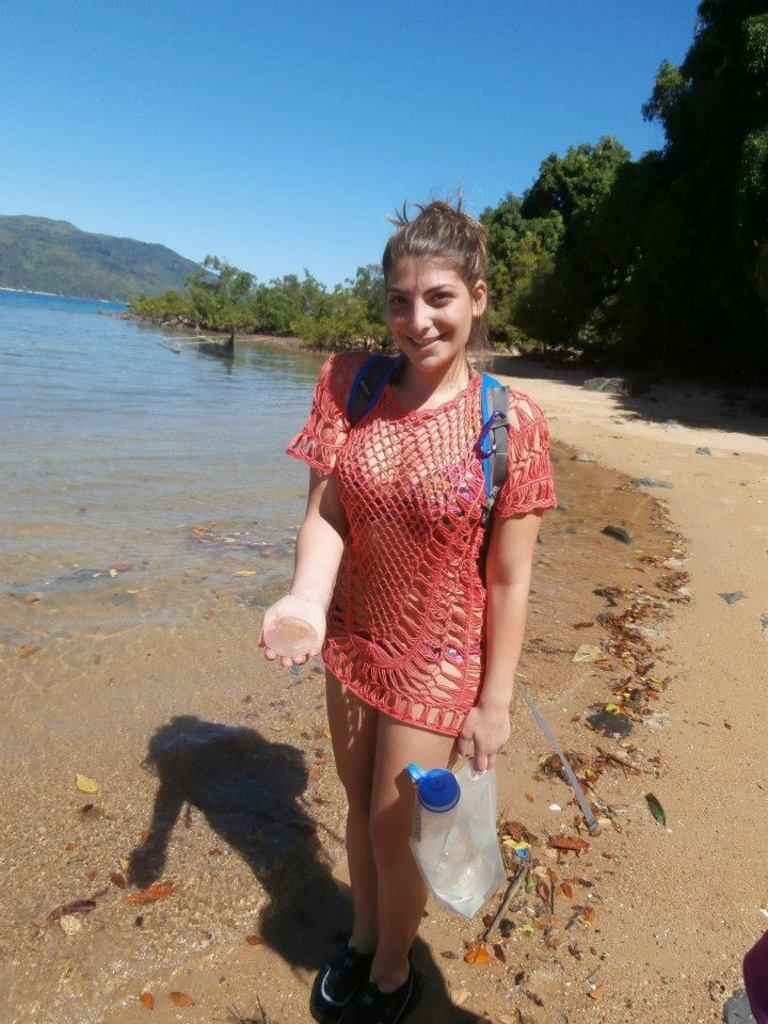Who is present in the image? There is a woman in the image. What can be seen in the background of the image? Water, trees, a mountain, and the sky are visible in the background of the image. What is the weight of the twig floating on the water in the image? There is no twig visible in the image, so it is not possible to determine its weight. 